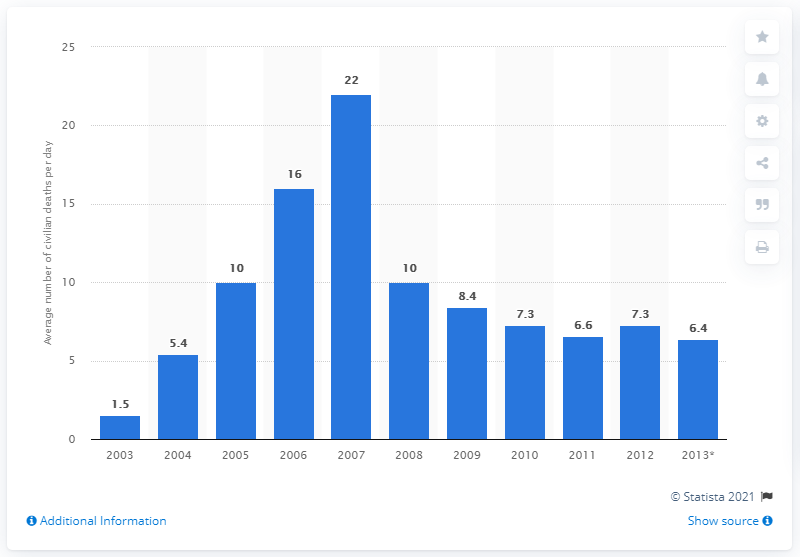Indicate a few pertinent items in this graphic. On January 19, 2013, the average number of civilian deaths per day caused by suicide attacks and car bombs was 6.4. 